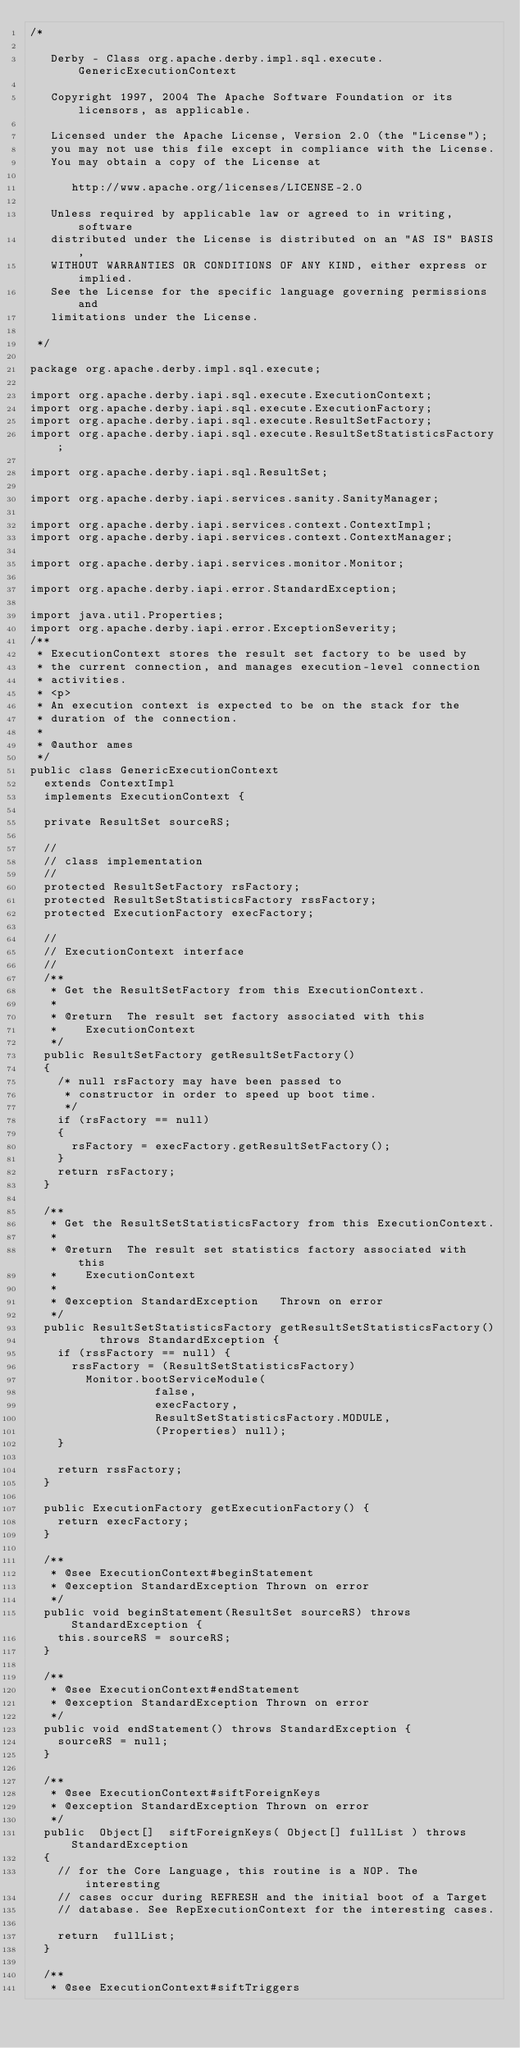<code> <loc_0><loc_0><loc_500><loc_500><_Java_>/*

   Derby - Class org.apache.derby.impl.sql.execute.GenericExecutionContext

   Copyright 1997, 2004 The Apache Software Foundation or its licensors, as applicable.

   Licensed under the Apache License, Version 2.0 (the "License");
   you may not use this file except in compliance with the License.
   You may obtain a copy of the License at

      http://www.apache.org/licenses/LICENSE-2.0

   Unless required by applicable law or agreed to in writing, software
   distributed under the License is distributed on an "AS IS" BASIS,
   WITHOUT WARRANTIES OR CONDITIONS OF ANY KIND, either express or implied.
   See the License for the specific language governing permissions and
   limitations under the License.

 */

package org.apache.derby.impl.sql.execute;

import org.apache.derby.iapi.sql.execute.ExecutionContext;
import org.apache.derby.iapi.sql.execute.ExecutionFactory;
import org.apache.derby.iapi.sql.execute.ResultSetFactory;
import org.apache.derby.iapi.sql.execute.ResultSetStatisticsFactory;

import org.apache.derby.iapi.sql.ResultSet;

import org.apache.derby.iapi.services.sanity.SanityManager;

import org.apache.derby.iapi.services.context.ContextImpl;
import org.apache.derby.iapi.services.context.ContextManager;

import org.apache.derby.iapi.services.monitor.Monitor;

import org.apache.derby.iapi.error.StandardException;

import java.util.Properties;
import org.apache.derby.iapi.error.ExceptionSeverity;
/**
 * ExecutionContext stores the result set factory to be used by
 * the current connection, and manages execution-level connection
 * activities.
 * <p>
 * An execution context is expected to be on the stack for the
 * duration of the connection.
 *
 * @author ames
 */
public class GenericExecutionContext
	extends ContextImpl 
	implements ExecutionContext {

	private ResultSet sourceRS;

	//
	// class implementation
	//
	protected ResultSetFactory rsFactory;
	protected ResultSetStatisticsFactory rssFactory;
	protected ExecutionFactory execFactory;

	//
	// ExecutionContext interface
	//
	/**
	 * Get the ResultSetFactory from this ExecutionContext.
	 *
	 * @return	The result set factory associated with this
	 *		ExecutionContext
	 */
	public ResultSetFactory getResultSetFactory() 
	{
		/* null rsFactory may have been passed to
		 * constructor in order to speed up boot time.
		 */
		if (rsFactory == null)
		{
			rsFactory = execFactory.getResultSetFactory();
		}
		return rsFactory;
	}

	/**
	 * Get the ResultSetStatisticsFactory from this ExecutionContext.
	 *
	 * @return	The result set statistics factory associated with this
	 *		ExecutionContext
	 *
	 * @exception StandardException		Thrown on error
	 */
	public ResultSetStatisticsFactory getResultSetStatisticsFactory()
					throws StandardException {
		if (rssFactory == null) {
			rssFactory = (ResultSetStatisticsFactory)
				Monitor.bootServiceModule(
									false,
									execFactory,
									ResultSetStatisticsFactory.MODULE,
									(Properties) null);
		}

		return rssFactory;
	}

	public ExecutionFactory getExecutionFactory() {
		return execFactory;
	}

	/**
	 * @see ExecutionContext#beginStatement
	 * @exception StandardException Thrown on error
	 */
	public void beginStatement(ResultSet sourceRS) throws StandardException {
		this.sourceRS = sourceRS;
	}

	/**
	 * @see ExecutionContext#endStatement
	 * @exception StandardException Thrown on error
	 */
	public void endStatement() throws StandardException {
		sourceRS = null;
	}

	/**
	 * @see ExecutionContext#siftForeignKeys
	 * @exception StandardException Thrown on error
	 */
	public	Object[]	siftForeignKeys( Object[] fullList ) throws StandardException
	{
		// for the Core Language, this routine is a NOP. The interesting
		// cases occur during REFRESH and the initial boot of a Target
		// database. See RepExecutionContext for the interesting cases.

		return	fullList;
	}

	/**
	 * @see ExecutionContext#siftTriggers</code> 